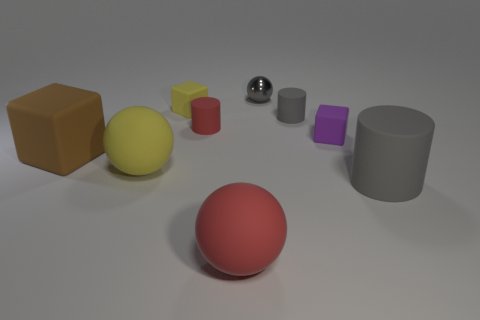The red rubber thing that is behind the gray matte cylinder that is in front of the small gray cylinder is what shape?
Make the answer very short. Cylinder. Are there an equal number of purple rubber objects that are on the left side of the gray shiny object and tiny purple cylinders?
Provide a short and direct response. Yes. There is a big cylinder; is its color the same as the ball behind the tiny red cylinder?
Provide a succinct answer. Yes. There is a ball that is in front of the tiny yellow matte block and behind the large red rubber sphere; what is its color?
Offer a terse response. Yellow. There is a large matte object right of the red sphere; what number of matte cubes are left of it?
Offer a terse response. 3. Is there a big yellow object that has the same shape as the tiny purple matte object?
Ensure brevity in your answer.  No. Is the shape of the matte thing on the left side of the large yellow rubber thing the same as the gray rubber object that is behind the large brown thing?
Offer a very short reply. No. How many things are either red matte things or rubber things?
Your response must be concise. 8. The yellow rubber object that is the same shape as the large brown object is what size?
Your answer should be very brief. Small. Are there more big objects to the right of the tiny red rubber cylinder than tiny gray spheres?
Provide a succinct answer. Yes. 